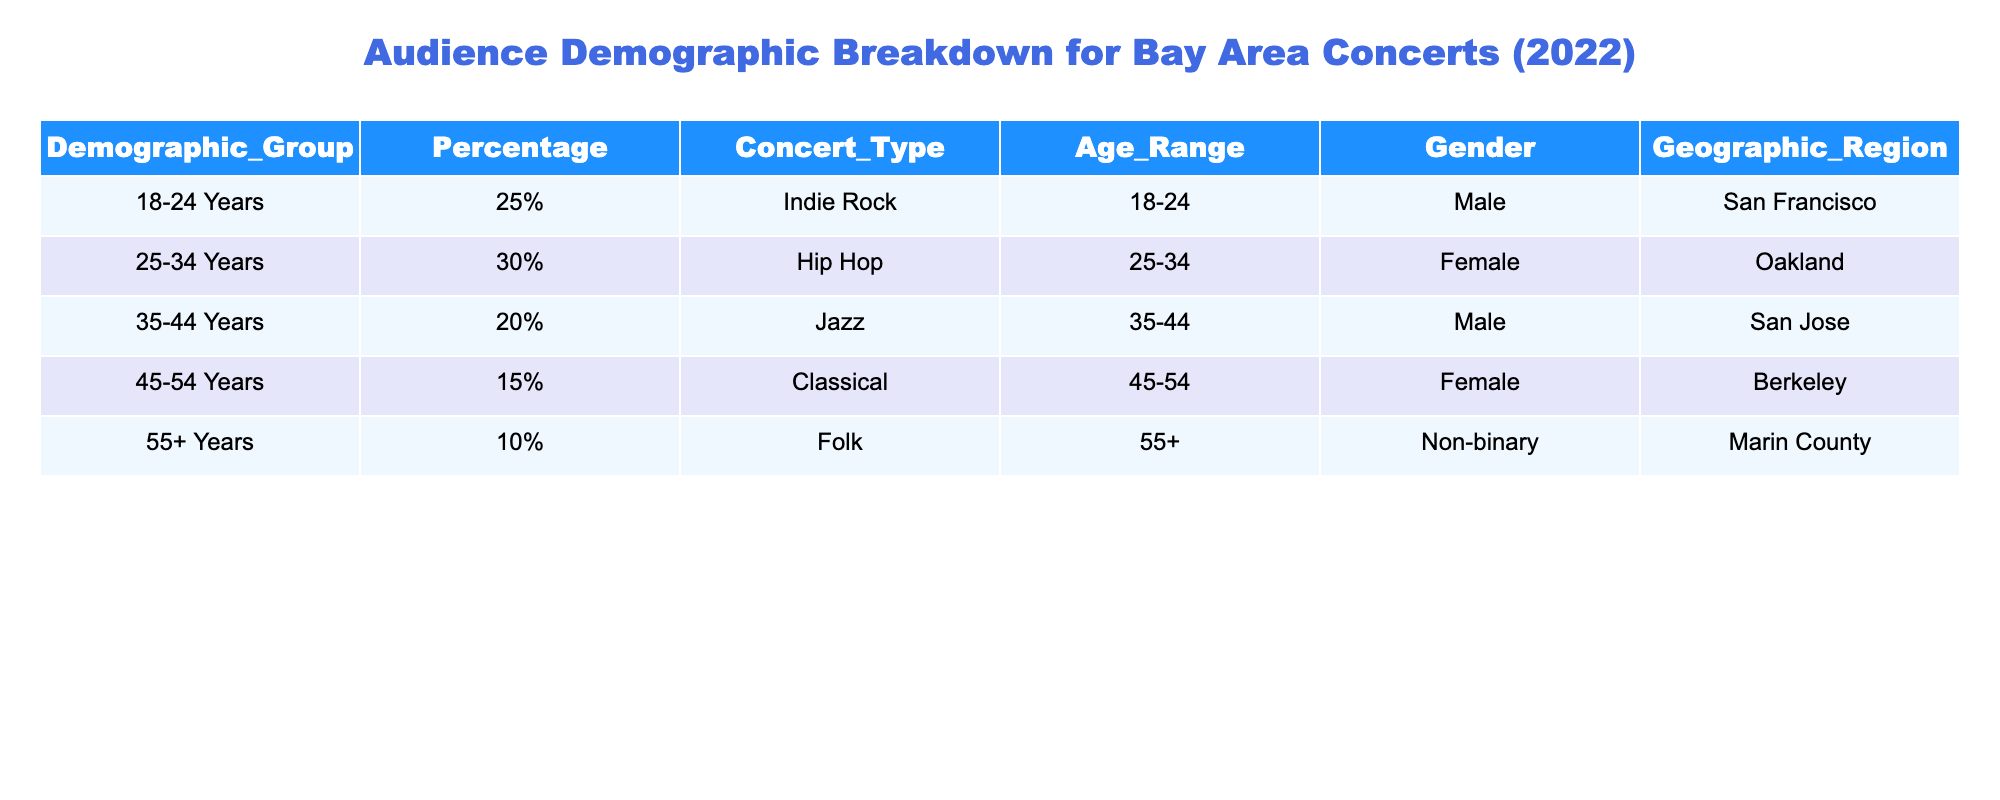What percentage of the audience belongs to the 25-34 age group? The table shows that the demographic group "25-34 Years" has a percentage of "30%." Therefore, the answer to the question is directly taken from the table.
Answer: 30% What is the concert type with the highest percentage of audience? By examining the percentages in the table, "Indie Rock" has a percentage of "25%," "Hip Hop" has "30%," "Jazz" has "20%," "Classical" has "15%," and "Folk" has "10%." The highest percentage is "30%" for "Hip Hop."
Answer: Hip Hop Is there a demographic group with representation from a Non-binary gender? The table indicates that "55+ Years" group includes "Non-binary" as a gender. As this data is present in the table, the answer is yes.
Answer: Yes What is the total percentage of males attending concerts? The table shows that "18-24 Years" (25%) and "35-44 Years" (20%) identify as male. Summing these percentages gives us 25% + 20% = 45%.
Answer: 45% Are there any concert types that attract more than 20% attendance from the 35-44 age group? The table indicates that the "Jazz" concert type is attended by the "35-44 Years" demographic group with a percentage of "20%." As there is no concert type shown with over 20%, the answer is no.
Answer: No Which geographic region has the lowest percentage representation in the concert demographics? The lowest percentage in the table is "10%" for "Folk" in the geographic region of "Marin County" because it only has representation from the Non-binary group. No other region has a lower percentage.
Answer: Marin County What is the average percentage of audience attendance for the 45-54 and 55+ age groups? For "45-54 Years," the percentage is "15%" and for "55+ Years," it is "10%." The average can be calculated as (15% + 10%) / 2 = 25% / 2 = 12.5%.
Answer: 12.5% Which concert type is popular among the 18-24 year age group? The table clearly states that the "Indie Rock" concert type corresponds with the "18-24 Years" demographic. Therefore, the answer can be retrieved directly from the table.
Answer: Indie Rock 